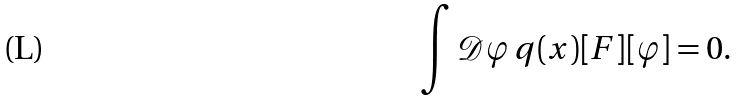<formula> <loc_0><loc_0><loc_500><loc_500>\int { \mathcal { D } } \varphi \, q ( x ) [ F ] [ \varphi ] = 0 .</formula> 